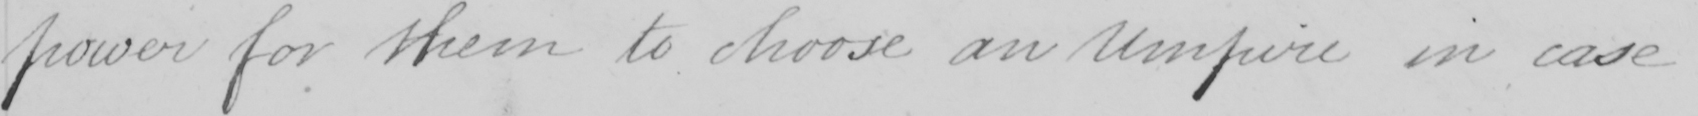What is written in this line of handwriting? power for them to choose an Umpire in case 